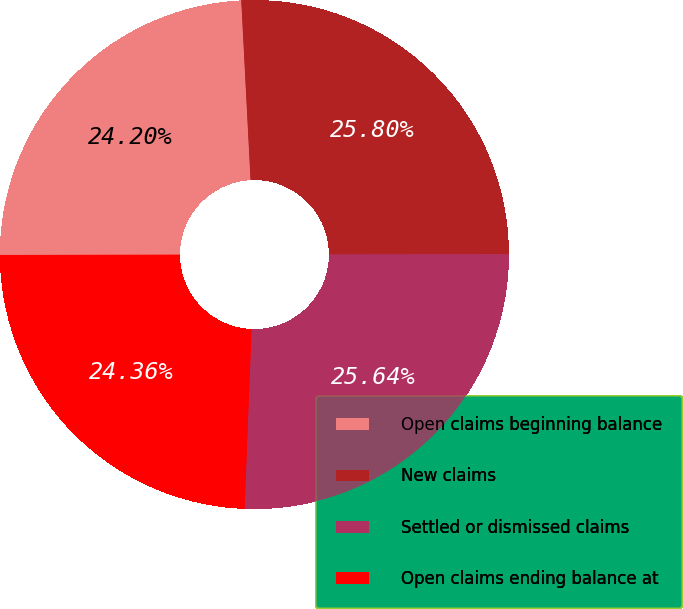Convert chart. <chart><loc_0><loc_0><loc_500><loc_500><pie_chart><fcel>Open claims beginning balance<fcel>New claims<fcel>Settled or dismissed claims<fcel>Open claims ending balance at<nl><fcel>24.2%<fcel>25.8%<fcel>25.64%<fcel>24.36%<nl></chart> 